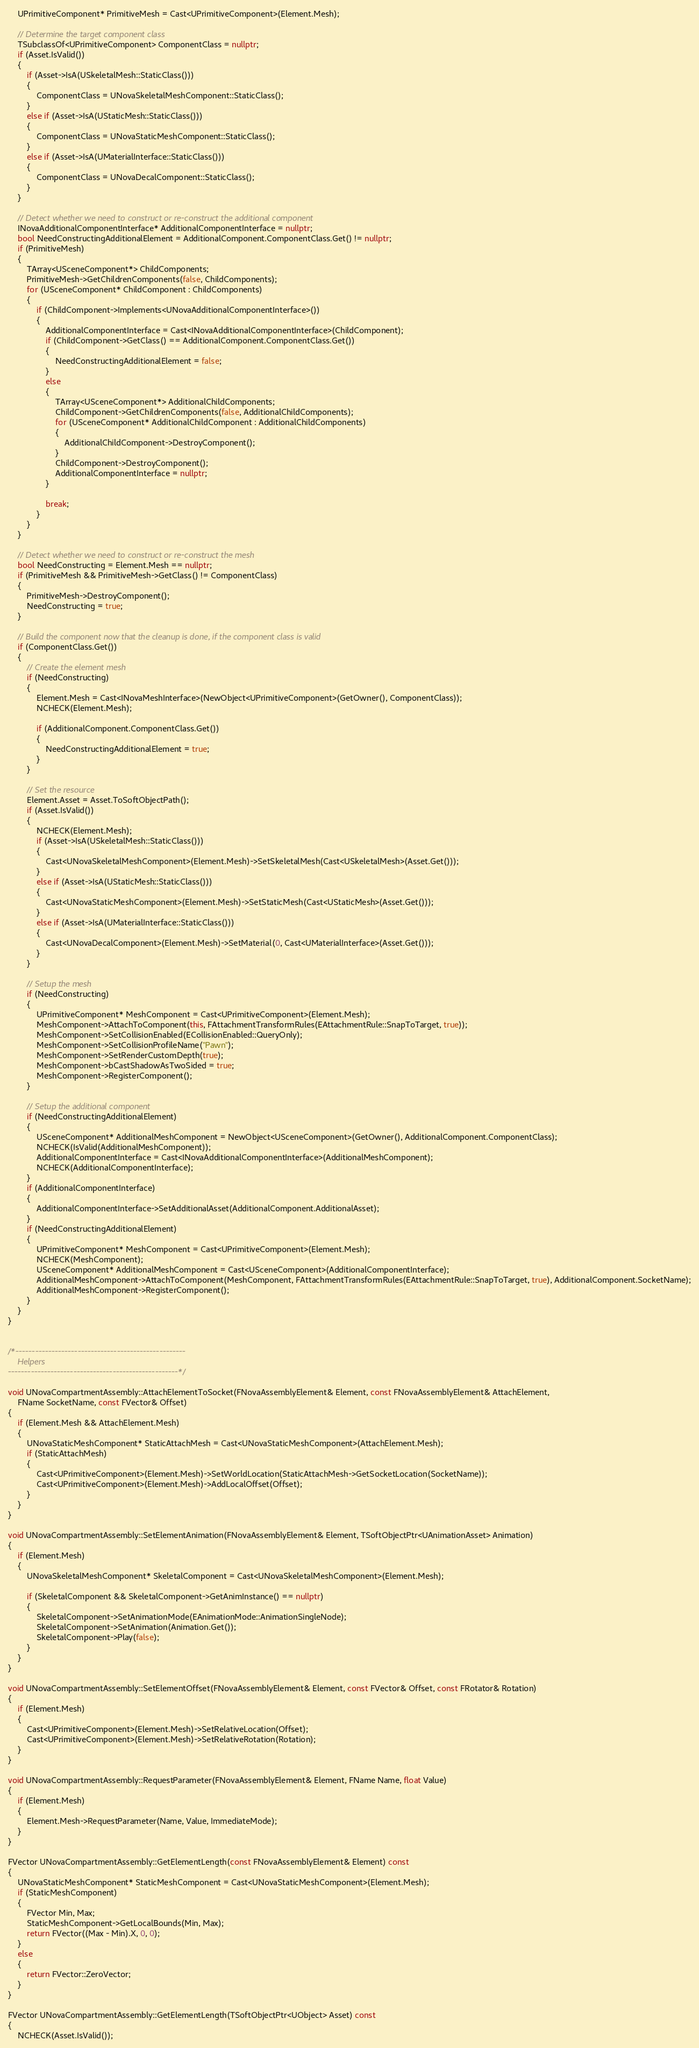Convert code to text. <code><loc_0><loc_0><loc_500><loc_500><_C++_>	UPrimitiveComponent* PrimitiveMesh = Cast<UPrimitiveComponent>(Element.Mesh);

	// Determine the target component class
	TSubclassOf<UPrimitiveComponent> ComponentClass = nullptr;
	if (Asset.IsValid())
	{
		if (Asset->IsA(USkeletalMesh::StaticClass()))
		{
			ComponentClass = UNovaSkeletalMeshComponent::StaticClass();
		}
		else if (Asset->IsA(UStaticMesh::StaticClass()))
		{
			ComponentClass = UNovaStaticMeshComponent::StaticClass();
		}
		else if (Asset->IsA(UMaterialInterface::StaticClass()))
		{
			ComponentClass = UNovaDecalComponent::StaticClass();
		}
	}

	// Detect whether we need to construct or re-construct the additional component
	INovaAdditionalComponentInterface* AdditionalComponentInterface = nullptr;
	bool NeedConstructingAdditionalElement = AdditionalComponent.ComponentClass.Get() != nullptr;
	if (PrimitiveMesh)
	{
		TArray<USceneComponent*> ChildComponents;
		PrimitiveMesh->GetChildrenComponents(false, ChildComponents);
		for (USceneComponent* ChildComponent : ChildComponents)
		{
			if (ChildComponent->Implements<UNovaAdditionalComponentInterface>())
			{
				AdditionalComponentInterface = Cast<INovaAdditionalComponentInterface>(ChildComponent);
				if (ChildComponent->GetClass() == AdditionalComponent.ComponentClass.Get())
				{
					NeedConstructingAdditionalElement = false;
				}
				else
				{
					TArray<USceneComponent*> AdditionalChildComponents;
					ChildComponent->GetChildrenComponents(false, AdditionalChildComponents);
					for (USceneComponent* AdditionalChildComponent : AdditionalChildComponents)
					{
						AdditionalChildComponent->DestroyComponent();
					}
					ChildComponent->DestroyComponent();
					AdditionalComponentInterface = nullptr;
				}

				break;
			}
		}
	}

	// Detect whether we need to construct or re-construct the mesh
	bool NeedConstructing = Element.Mesh == nullptr;
	if (PrimitiveMesh && PrimitiveMesh->GetClass() != ComponentClass)
	{
		PrimitiveMesh->DestroyComponent();
		NeedConstructing = true;
	}

	// Build the component now that the cleanup is done, if the component class is valid
	if (ComponentClass.Get())
	{
		// Create the element mesh
		if (NeedConstructing)
		{
			Element.Mesh = Cast<INovaMeshInterface>(NewObject<UPrimitiveComponent>(GetOwner(), ComponentClass));
			NCHECK(Element.Mesh);

			if (AdditionalComponent.ComponentClass.Get())
			{
				NeedConstructingAdditionalElement = true;
			}
		}

		// Set the resource
		Element.Asset = Asset.ToSoftObjectPath();
		if (Asset.IsValid())
		{
			NCHECK(Element.Mesh);
			if (Asset->IsA(USkeletalMesh::StaticClass()))
			{
				Cast<UNovaSkeletalMeshComponent>(Element.Mesh)->SetSkeletalMesh(Cast<USkeletalMesh>(Asset.Get()));
			}
			else if (Asset->IsA(UStaticMesh::StaticClass()))
			{
				Cast<UNovaStaticMeshComponent>(Element.Mesh)->SetStaticMesh(Cast<UStaticMesh>(Asset.Get()));
			}
			else if (Asset->IsA(UMaterialInterface::StaticClass()))
			{
				Cast<UNovaDecalComponent>(Element.Mesh)->SetMaterial(0, Cast<UMaterialInterface>(Asset.Get()));
			}
		}

		// Setup the mesh
		if (NeedConstructing)
		{
			UPrimitiveComponent* MeshComponent = Cast<UPrimitiveComponent>(Element.Mesh);
			MeshComponent->AttachToComponent(this, FAttachmentTransformRules(EAttachmentRule::SnapToTarget, true));
			MeshComponent->SetCollisionEnabled(ECollisionEnabled::QueryOnly);
			MeshComponent->SetCollisionProfileName("Pawn");
			MeshComponent->SetRenderCustomDepth(true);
			MeshComponent->bCastShadowAsTwoSided = true;
			MeshComponent->RegisterComponent();
		}

		// Setup the additional component
		if (NeedConstructingAdditionalElement)
		{
			USceneComponent* AdditionalMeshComponent = NewObject<USceneComponent>(GetOwner(), AdditionalComponent.ComponentClass);
			NCHECK(IsValid(AdditionalMeshComponent));
			AdditionalComponentInterface = Cast<INovaAdditionalComponentInterface>(AdditionalMeshComponent);
			NCHECK(AdditionalComponentInterface);
		}
		if (AdditionalComponentInterface)
		{
			AdditionalComponentInterface->SetAdditionalAsset(AdditionalComponent.AdditionalAsset);
		}
		if (NeedConstructingAdditionalElement)
		{
			UPrimitiveComponent* MeshComponent = Cast<UPrimitiveComponent>(Element.Mesh);
			NCHECK(MeshComponent);
			USceneComponent* AdditionalMeshComponent = Cast<USceneComponent>(AdditionalComponentInterface);
			AdditionalMeshComponent->AttachToComponent(MeshComponent, FAttachmentTransformRules(EAttachmentRule::SnapToTarget, true), AdditionalComponent.SocketName);
			AdditionalMeshComponent->RegisterComponent();
		}
	}
}


/*----------------------------------------------------
	Helpers
----------------------------------------------------*/

void UNovaCompartmentAssembly::AttachElementToSocket(FNovaAssemblyElement& Element, const FNovaAssemblyElement& AttachElement,
	FName SocketName, const FVector& Offset)
{
	if (Element.Mesh && AttachElement.Mesh)
	{
		UNovaStaticMeshComponent* StaticAttachMesh = Cast<UNovaStaticMeshComponent>(AttachElement.Mesh);
		if (StaticAttachMesh)
		{
			Cast<UPrimitiveComponent>(Element.Mesh)->SetWorldLocation(StaticAttachMesh->GetSocketLocation(SocketName));
			Cast<UPrimitiveComponent>(Element.Mesh)->AddLocalOffset(Offset);
		}
	}
}

void UNovaCompartmentAssembly::SetElementAnimation(FNovaAssemblyElement& Element, TSoftObjectPtr<UAnimationAsset> Animation)
{
	if (Element.Mesh)
	{
		UNovaSkeletalMeshComponent* SkeletalComponent = Cast<UNovaSkeletalMeshComponent>(Element.Mesh);

		if (SkeletalComponent && SkeletalComponent->GetAnimInstance() == nullptr)
		{
			SkeletalComponent->SetAnimationMode(EAnimationMode::AnimationSingleNode);
			SkeletalComponent->SetAnimation(Animation.Get());
			SkeletalComponent->Play(false);
		}
	}
}

void UNovaCompartmentAssembly::SetElementOffset(FNovaAssemblyElement& Element, const FVector& Offset, const FRotator& Rotation)
{
	if (Element.Mesh)
	{
		Cast<UPrimitiveComponent>(Element.Mesh)->SetRelativeLocation(Offset);
		Cast<UPrimitiveComponent>(Element.Mesh)->SetRelativeRotation(Rotation);
	}
}

void UNovaCompartmentAssembly::RequestParameter(FNovaAssemblyElement& Element, FName Name, float Value)
{
	if (Element.Mesh)
	{
		Element.Mesh->RequestParameter(Name, Value, ImmediateMode);
	}
}

FVector UNovaCompartmentAssembly::GetElementLength(const FNovaAssemblyElement& Element) const
{
	UNovaStaticMeshComponent* StaticMeshComponent = Cast<UNovaStaticMeshComponent>(Element.Mesh);
	if (StaticMeshComponent)
	{
		FVector Min, Max;
		StaticMeshComponent->GetLocalBounds(Min, Max);
		return FVector((Max - Min).X, 0, 0);
	}
	else
	{
		return FVector::ZeroVector;
	}
}

FVector UNovaCompartmentAssembly::GetElementLength(TSoftObjectPtr<UObject> Asset) const
{
	NCHECK(Asset.IsValid());
</code> 